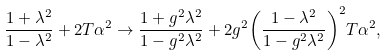<formula> <loc_0><loc_0><loc_500><loc_500>\frac { { 1 + { \lambda ^ { 2 } } } } { { 1 - { \lambda ^ { 2 } } } } + 2 T { \alpha ^ { 2 } } \to \frac { { 1 + { g ^ { 2 } } { \lambda ^ { 2 } } } } { { 1 - { g ^ { 2 } } { \lambda ^ { 2 } } } } + 2 { g ^ { 2 } } { \left ( { \frac { { 1 - { \lambda ^ { 2 } } } } { { 1 - { g ^ { 2 } } { \lambda ^ { 2 } } } } } \right ) ^ { 2 } } T { \alpha ^ { 2 } } ,</formula> 